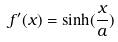<formula> <loc_0><loc_0><loc_500><loc_500>f ^ { \prime } ( x ) = \sinh ( \frac { x } { a } )</formula> 